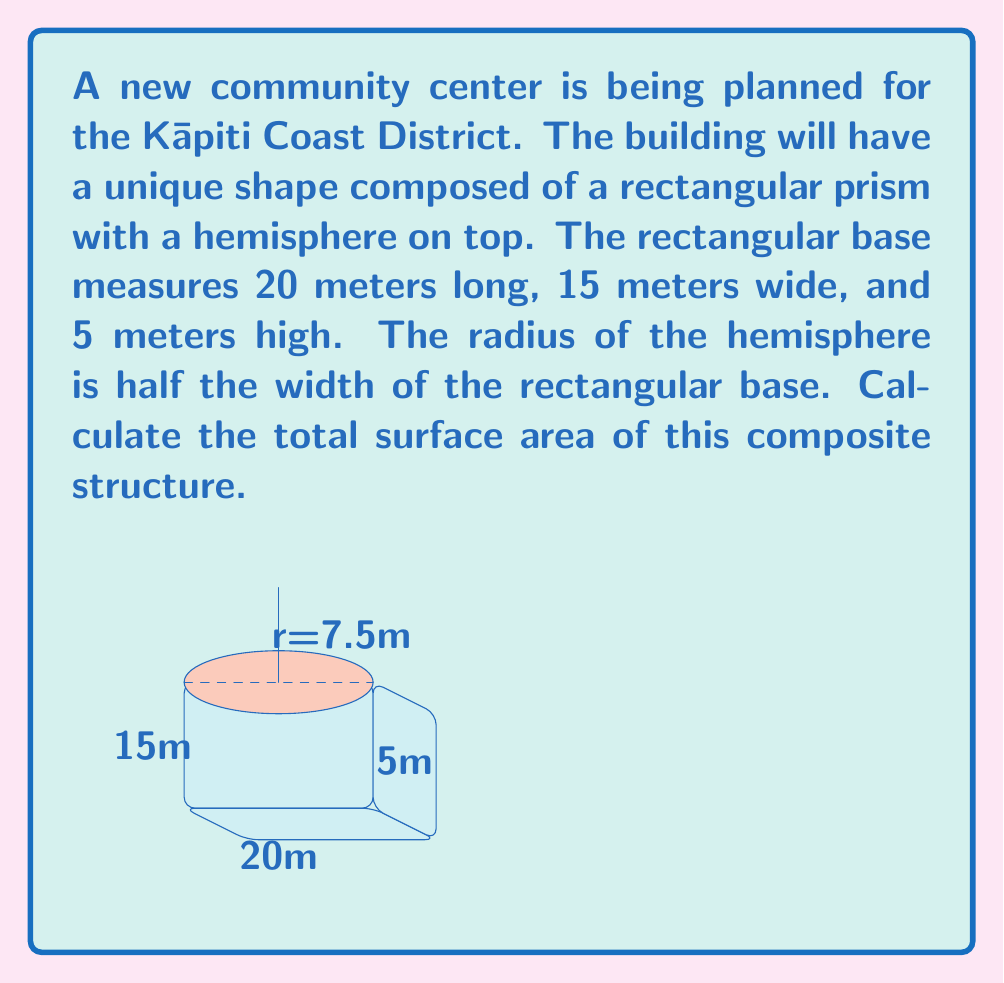Could you help me with this problem? Let's break this down step-by-step:

1) First, let's calculate the surface area of the rectangular prism:
   - Base: $20 \times 15 = 300$ m²
   - Front and back: $2 \times (20 \times 5) = 200$ m²
   - Left and right sides: $2 \times (15 \times 5) = 150$ m²
   Total for rectangular prism: $300 + 200 + 150 = 650$ m²

2) Now, let's calculate the surface area of the hemisphere:
   - The radius of the hemisphere is half the width of the base: $15 \div 2 = 7.5$ m
   - Surface area of a hemisphere: $2\pi r^2$
   - $SA_{hemisphere} = 2\pi (7.5)^2 = 353.43$ m²

3) However, we need to subtract the area of the circular base of the hemisphere, as this is where it connects to the rectangular prism:
   - Area of circle: $\pi r^2 = \pi (7.5)^2 = 176.71$ m²

4) Total surface area:
   $$ SA_{total} = SA_{prism} + SA_{hemisphere} - SA_{circle} $$
   $$ SA_{total} = 650 + 353.43 - 176.71 = 826.72 \text{ m}^2 $$
Answer: $826.72 \text{ m}^2$ 